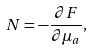Convert formula to latex. <formula><loc_0><loc_0><loc_500><loc_500>N = - \frac { \partial F } { \partial \mu _ { a } } ,</formula> 